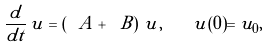Convert formula to latex. <formula><loc_0><loc_0><loc_500><loc_500>\frac { d } { d t } \, u = \left ( \ A + \ B \right ) \, u , \quad u ( 0 ) = u _ { 0 } ,</formula> 